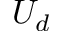<formula> <loc_0><loc_0><loc_500><loc_500>U _ { d }</formula> 